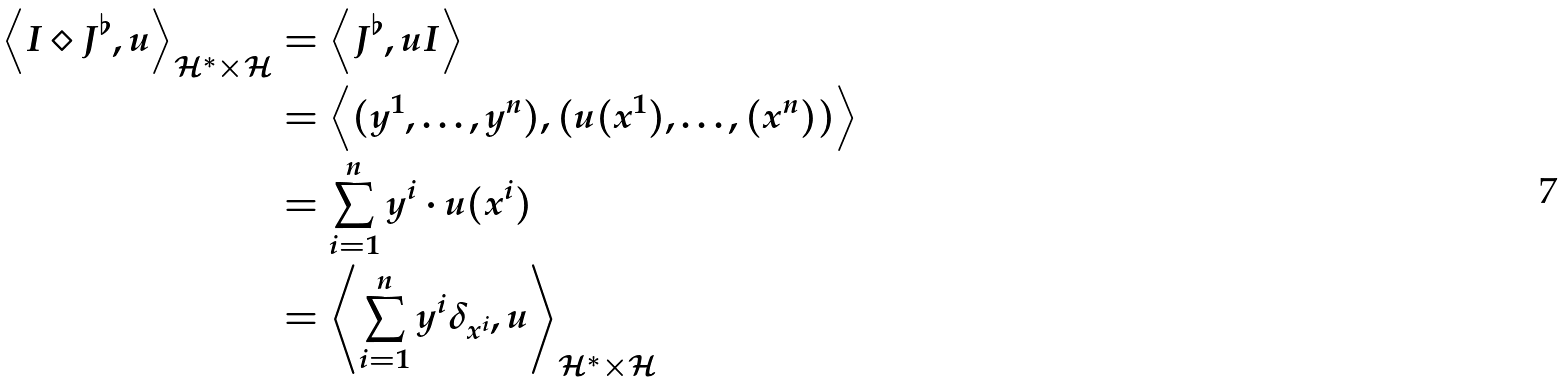<formula> <loc_0><loc_0><loc_500><loc_500>\left \langle I \diamond J ^ { \flat } , u \right \rangle _ { \mathcal { H } ^ { \ast } \times \mathcal { H } } & = \left \langle J ^ { \flat } , u I \right \rangle \\ & = \left \langle ( y ^ { 1 } , \dots , y ^ { n } ) , ( u ( x ^ { 1 } ) , \dots , ( x ^ { n } ) ) \right \rangle \\ & = \sum _ { i = 1 } ^ { n } y ^ { i } \cdot u ( x ^ { i } ) \\ & = \left \langle \sum _ { i = 1 } ^ { n } y ^ { i } \delta _ { x ^ { i } } , u \right \rangle _ { \mathcal { H } ^ { \ast } \times \mathcal { H } }</formula> 